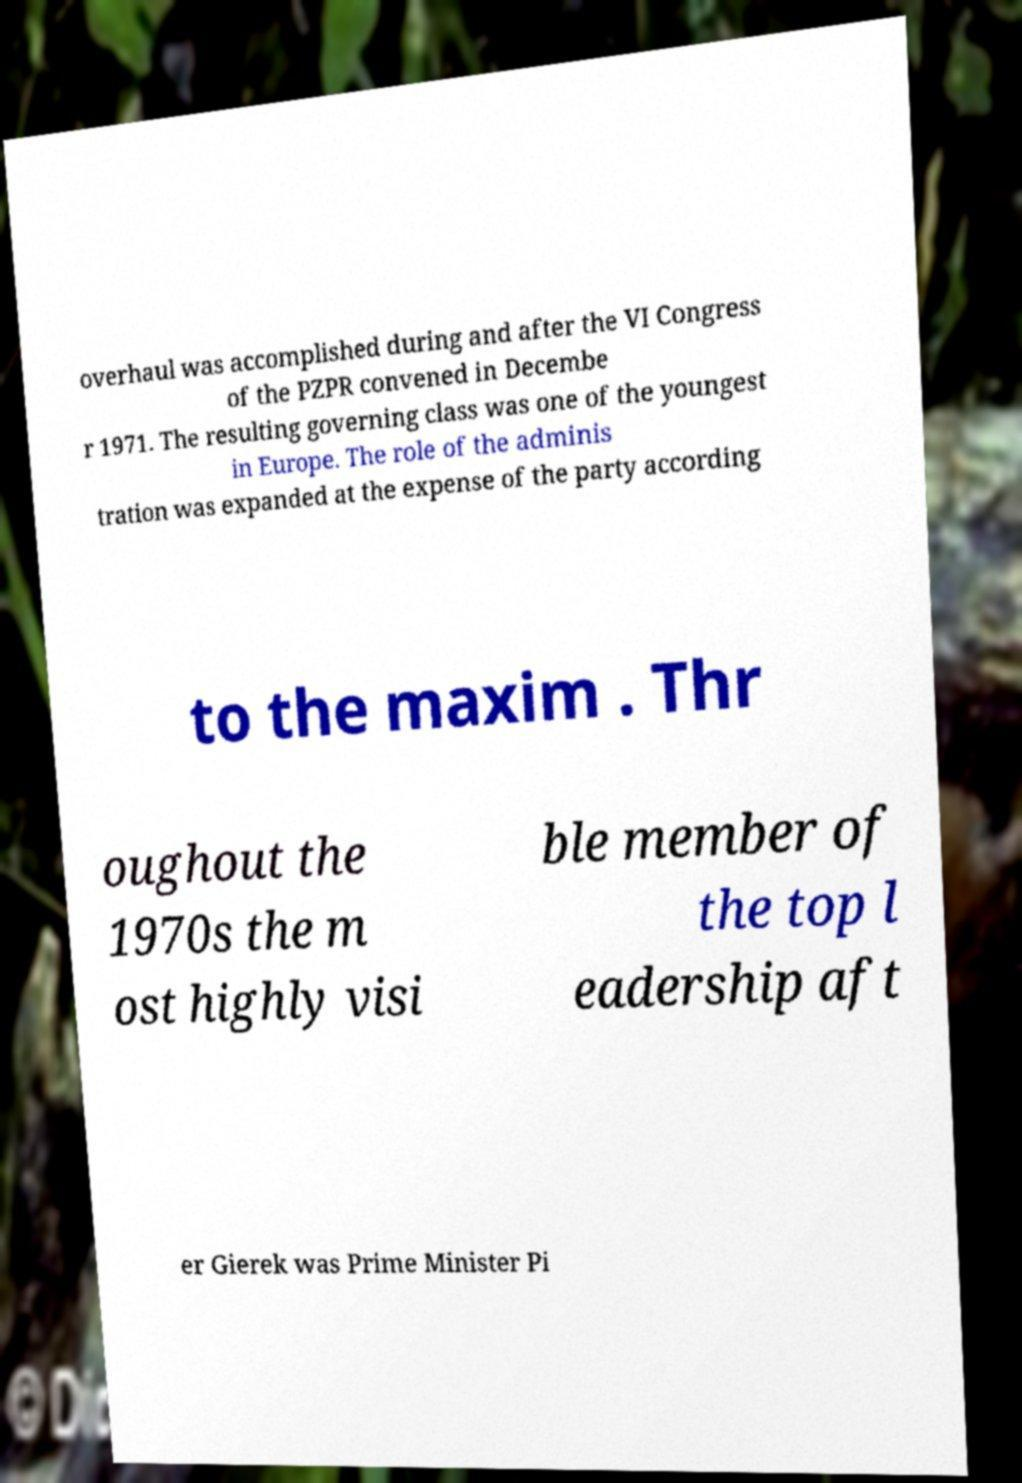Can you accurately transcribe the text from the provided image for me? overhaul was accomplished during and after the VI Congress of the PZPR convened in Decembe r 1971. The resulting governing class was one of the youngest in Europe. The role of the adminis tration was expanded at the expense of the party according to the maxim . Thr oughout the 1970s the m ost highly visi ble member of the top l eadership aft er Gierek was Prime Minister Pi 